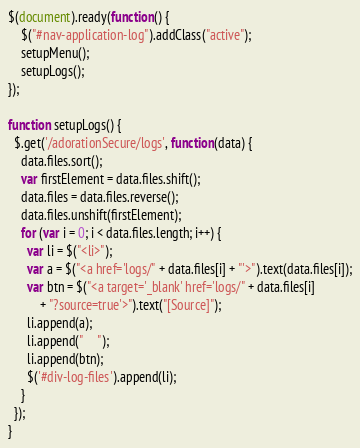<code> <loc_0><loc_0><loc_500><loc_500><_JavaScript_>$(document).ready(function() {
    $("#nav-application-log").addClass("active");
    setupMenu();
    setupLogs();
});

function setupLogs() {
  $.get('/adorationSecure/logs', function(data) {
	data.files.sort();
    var firstElement = data.files.shift();
    data.files = data.files.reverse();
    data.files.unshift(firstElement);
    for (var i = 0; i < data.files.length; i++) {
      var li = $("<li>");
      var a = $("<a href='logs/" + data.files[i] + "'>").text(data.files[i]);
      var btn = $("<a target='_blank' href='logs/" + data.files[i]
          + "?source=true'>").text("[Source]");
      li.append(a);
      li.append("     ");
      li.append(btn);
      $('#div-log-files').append(li);
    }
  });
}
</code> 